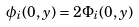Convert formula to latex. <formula><loc_0><loc_0><loc_500><loc_500>\phi _ { i } ( 0 , y ) = 2 \Phi _ { i } ( 0 , y )</formula> 